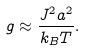<formula> <loc_0><loc_0><loc_500><loc_500>g \approx \frac { J ^ { 2 } a ^ { 2 } } { k _ { B } T } .</formula> 